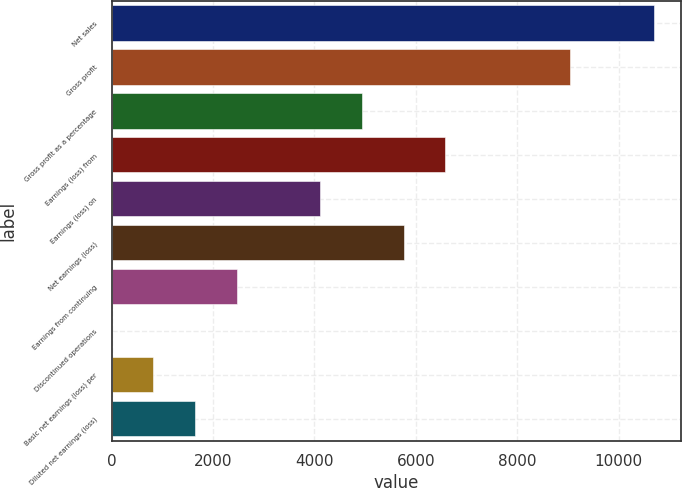Convert chart. <chart><loc_0><loc_0><loc_500><loc_500><bar_chart><fcel>Net sales<fcel>Gross profit<fcel>Gross profit as a percentage<fcel>Earnings (loss) from<fcel>Earnings (loss) on<fcel>Net earnings (loss)<fcel>Earnings from continuing<fcel>Discontinued operations<fcel>Basic net earnings (loss) per<fcel>Diluted net earnings (loss)<nl><fcel>10698.1<fcel>9052.26<fcel>4937.61<fcel>6583.47<fcel>4114.68<fcel>5760.54<fcel>2468.82<fcel>0.03<fcel>822.96<fcel>1645.89<nl></chart> 